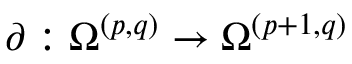<formula> <loc_0><loc_0><loc_500><loc_500>\partial \colon \Omega ^ { ( p , q ) } \to \Omega ^ { ( p + 1 , q ) }</formula> 